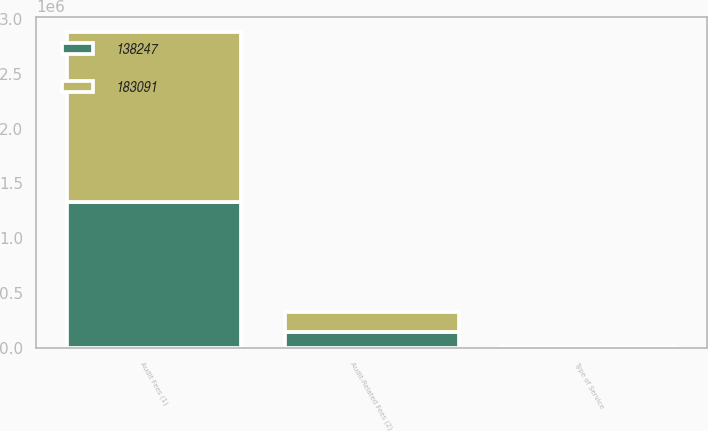Convert chart to OTSL. <chart><loc_0><loc_0><loc_500><loc_500><stacked_bar_chart><ecel><fcel>Type of Service<fcel>Audit Fees (1)<fcel>Audit-Related Fees (2)<nl><fcel>138247<fcel>2010<fcel>1.33017e+06<fcel>138247<nl><fcel>183091<fcel>2011<fcel>1.54772e+06<fcel>183091<nl></chart> 